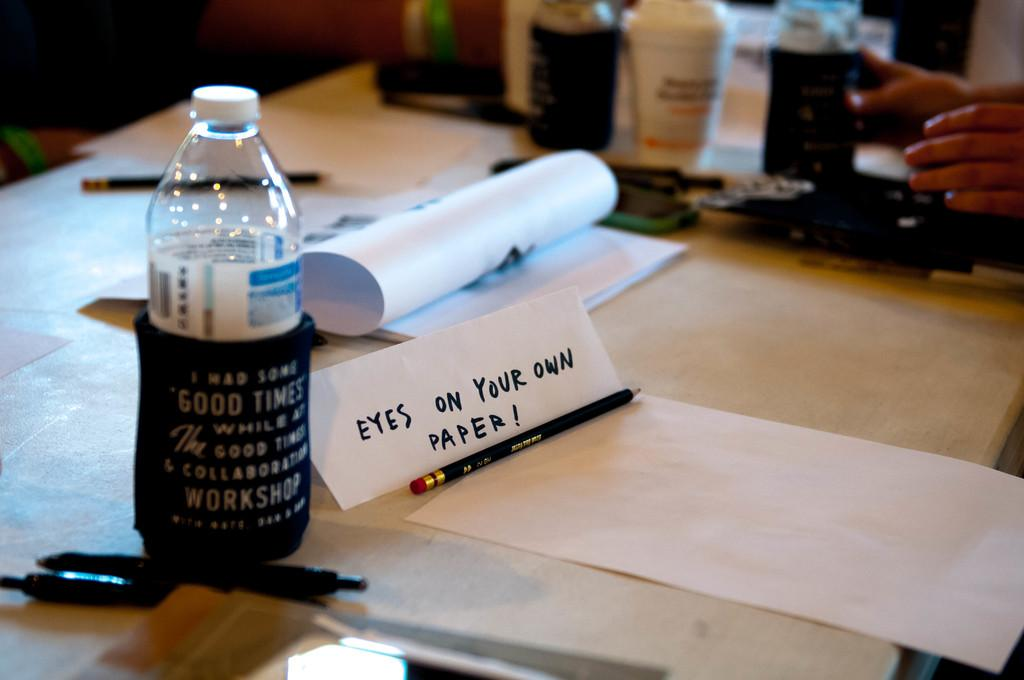<image>
Write a terse but informative summary of the picture. A work desk with pens, a water bottle and paper on it. One piece of paper is folded into a sign that says Eyes on Your Own Paper 